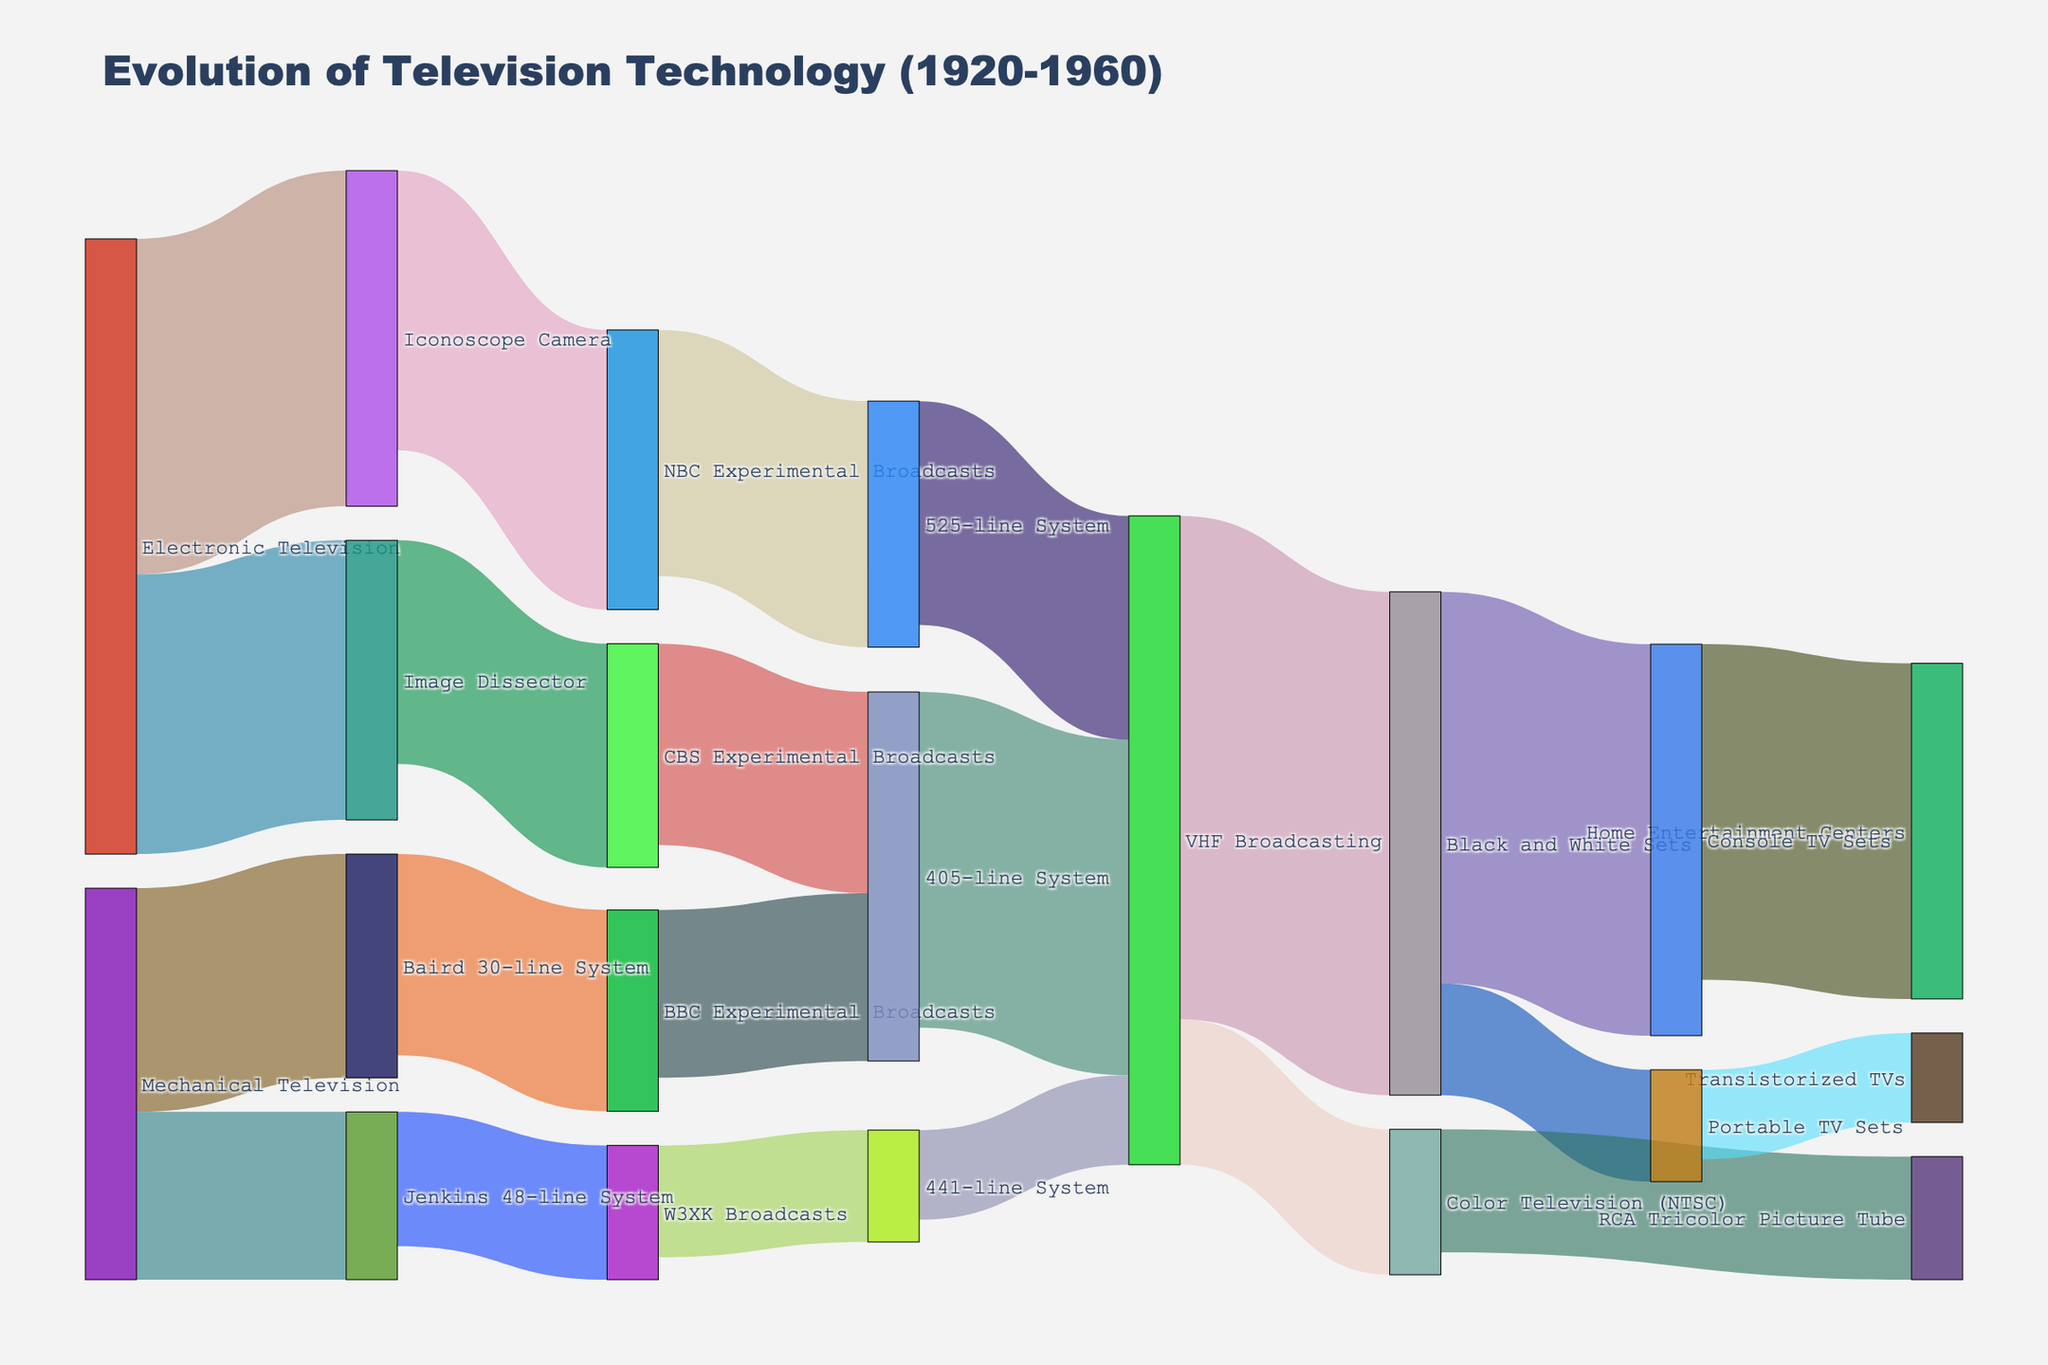what is the title of the figure? The title is typically at the top of the diagram and provides an overview of the content. In this case, it states the main subject of the visualization.
Answer: "Evolution of Television Technology (1920-1960)" Which display type had the most significant transition to another technology? By looking at the width of the bands in the Sankey diagram, you can see that "Electronic Television" transitions significantly to "Iconoscope Camera" with a value of 30.
Answer: Electronic Television to Iconoscope Camera How many display types transitioned to VHF Broadcasting? Count the number of flows that end in "VHF Broadcasting". The diagram shows three flows from "405-line System", "441-line System", and "525-line System".
Answer: Three Which system had the highest number of experimental broadcasts? Compare the values of "BBC Experimental Broadcasts", "W3XK Broadcasts", "NBC Experimental Broadcasts", and "CBS Experimental Broadcasts". "NBC Experimental Broadcasts" has the highest value of 25.
Answer: NBC Experimental Broadcasts What technology did the Baird 30-line System transition to? Trace the flow from "Baird 30-line System" to its target. It transitions to "BBC Experimental Broadcasts" with a value of 18.
Answer: BBC Experimental Broadcasts What is the total value for VHF Broadcasting flow? Add the values flowing into "VHF Broadcasting" from "405-line System" (30), "441-line System" (8), and "525-line System" (20). 30 + 8 + 20 = 58.
Answer: 58 Which broadcasting method transitioned to both Black and White Sets and Color Television (NTSC)? Identify flows originating from the same source. "VHF Broadcasting" transitions to both "Black and White Sets" and "Color Television (NTSC)" with values of 45 and 13, respectively.
Answer: VHF Broadcasting What is the smallest transition value shown in the diagram? Find the lowest value listed in the flows. The smallest value is 8 for "441-line System" to "VHF Broadcasting" and "Portable TV Sets" to "Transistorized TVs".
Answer: 8 Which technology had more value flowing into Console TV Sets, Black and White Sets, or Portable TV Sets? Compare the values flowing into "Console TV Sets" from "Black and White Sets" (35) and Portable TV Sets (N/A). The flow of 35 from "Black and White Sets" is larger.
Answer: Black and White Sets What percentage of the flow from "Electronic Television" went to the "Iconoscope Camera"? Calculate the total flow from "Electronic Television" and the proportion that went to "Iconoscope Camera". The flow is 30 for "Iconoscope Camera" out of a total of 55 (30 from Iconoscope Camera + 25 from Image Dissector), resulting in (30/55) * 100 ≈ 54.55%.
Answer: 54.55% 